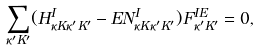<formula> <loc_0><loc_0><loc_500><loc_500>\sum _ { \kappa ^ { \prime } K ^ { \prime } } ( H ^ { I } _ { \kappa K \kappa ^ { \prime } K ^ { \prime } } - E N ^ { I } _ { \kappa K \kappa ^ { \prime } K ^ { \prime } } ) F ^ { I E } _ { \kappa ^ { \prime } K ^ { \prime } } = 0 ,</formula> 